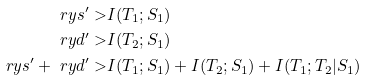Convert formula to latex. <formula><loc_0><loc_0><loc_500><loc_500>\ r y s ^ { \prime } > & I ( T _ { 1 } ; S _ { 1 } ) \\ \ r y d ^ { \prime } > & I ( T _ { 2 } ; S _ { 1 } ) \\ \ r y s ^ { \prime } + \ r y d ^ { \prime } > & I ( T _ { 1 } ; S _ { 1 } ) + I ( T _ { 2 } ; S _ { 1 } ) + I ( T _ { 1 } ; T _ { 2 } | S _ { 1 } )</formula> 